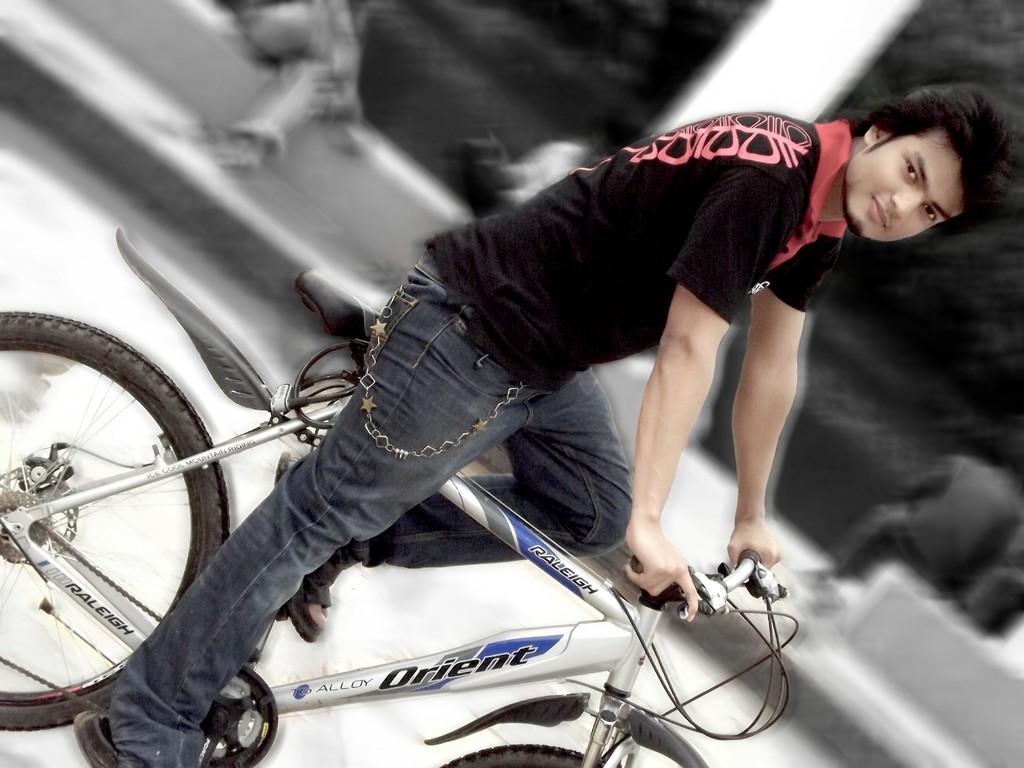Describe this image in one or two sentences. Boy riding bicycle. 